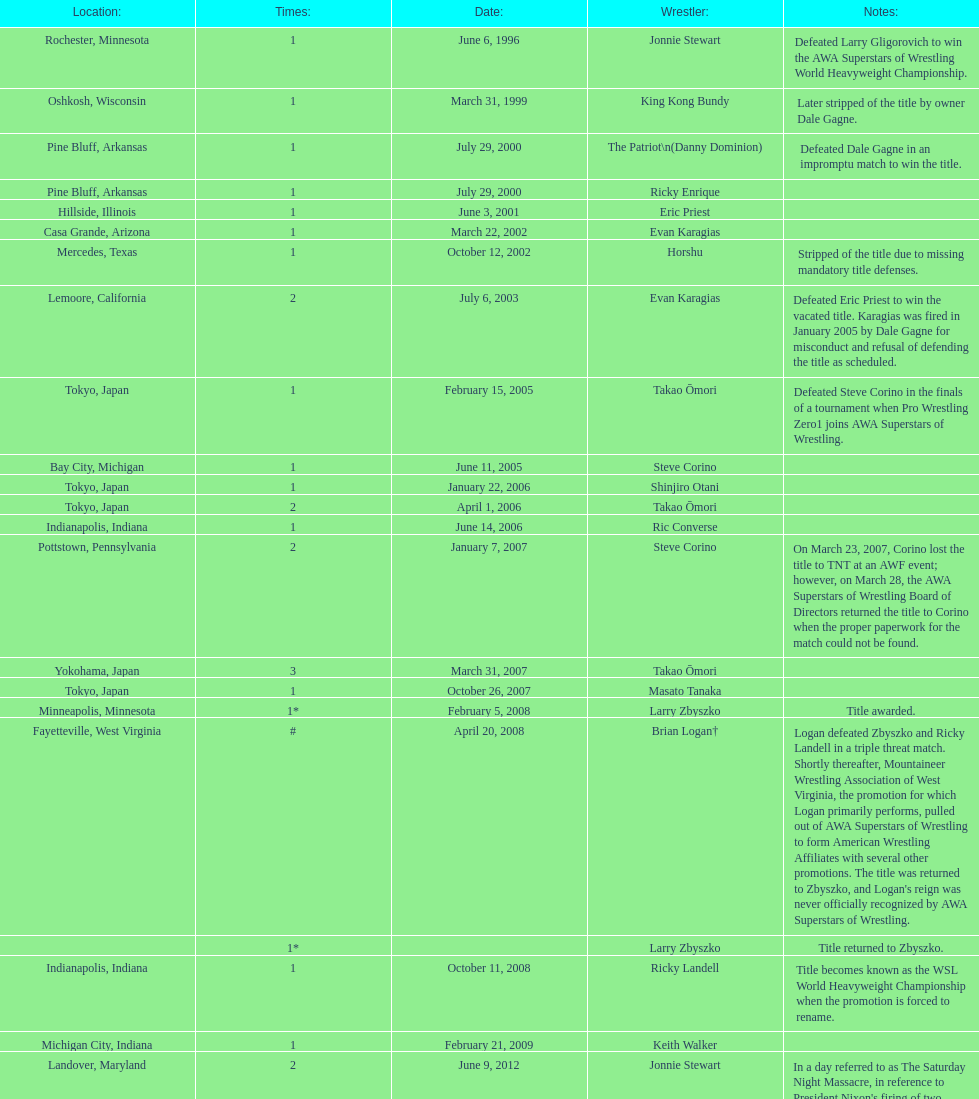Who is the only wsl title holder from texas? Horshu. 